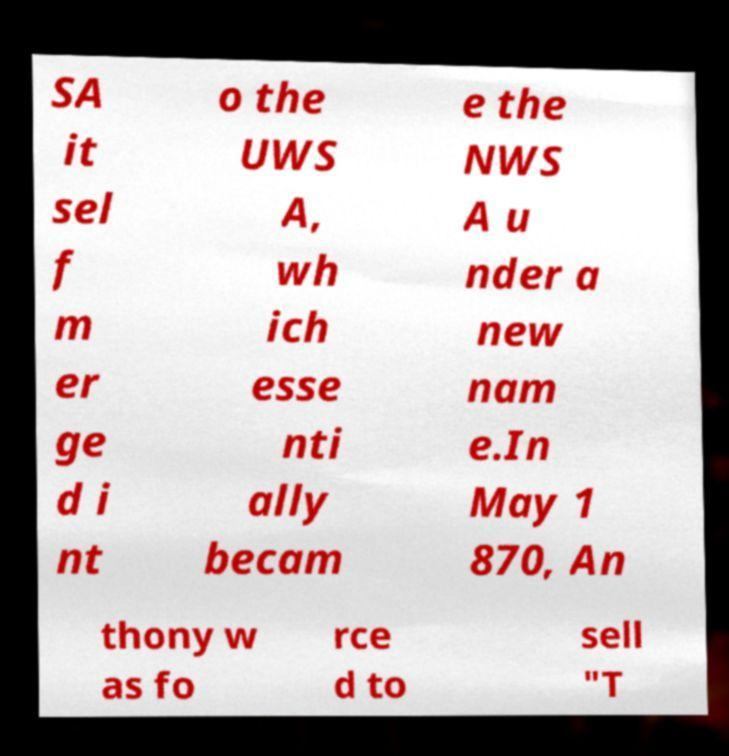Please read and relay the text visible in this image. What does it say? SA it sel f m er ge d i nt o the UWS A, wh ich esse nti ally becam e the NWS A u nder a new nam e.In May 1 870, An thony w as fo rce d to sell "T 